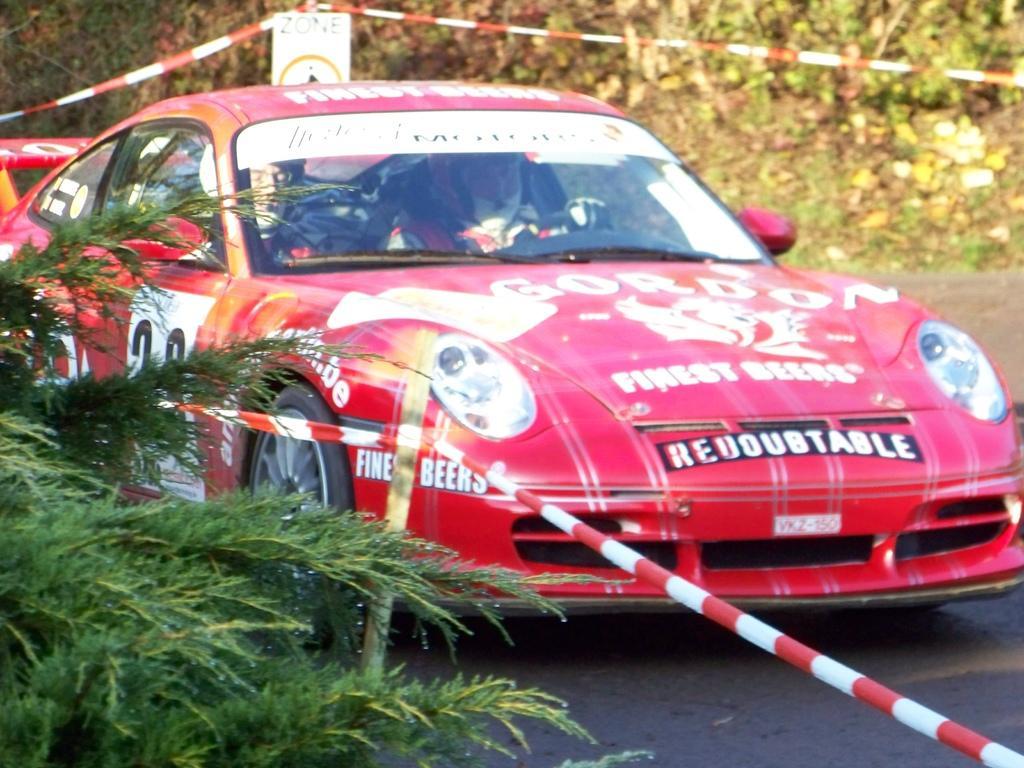Could you give a brief overview of what you see in this image? In this image can see a red color car, in the car I can see two persons and at the top I can see a red color rod , on the left side I can see plants and red color rod. 